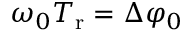Convert formula to latex. <formula><loc_0><loc_0><loc_500><loc_500>\omega _ { 0 } T _ { r } = \Delta \varphi _ { 0 }</formula> 